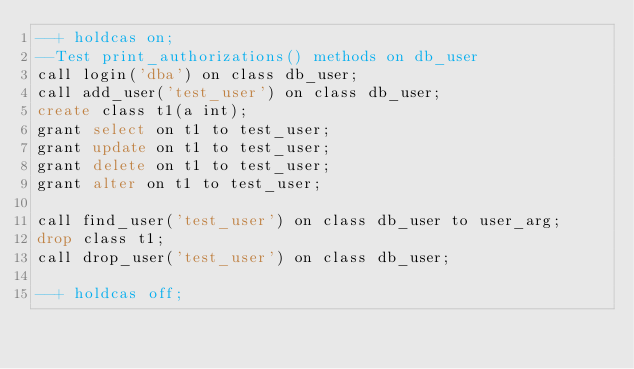<code> <loc_0><loc_0><loc_500><loc_500><_SQL_>--+ holdcas on;
--Test print_authorizations() methods on db_user
call login('dba') on class db_user;
call add_user('test_user') on class db_user;
create class t1(a int);
grant select on t1 to test_user;
grant update on t1 to test_user;
grant delete on t1 to test_user;
grant alter on t1 to test_user;

call find_user('test_user') on class db_user to user_arg;
drop class t1;
call drop_user('test_user') on class db_user;

--+ holdcas off;
</code> 